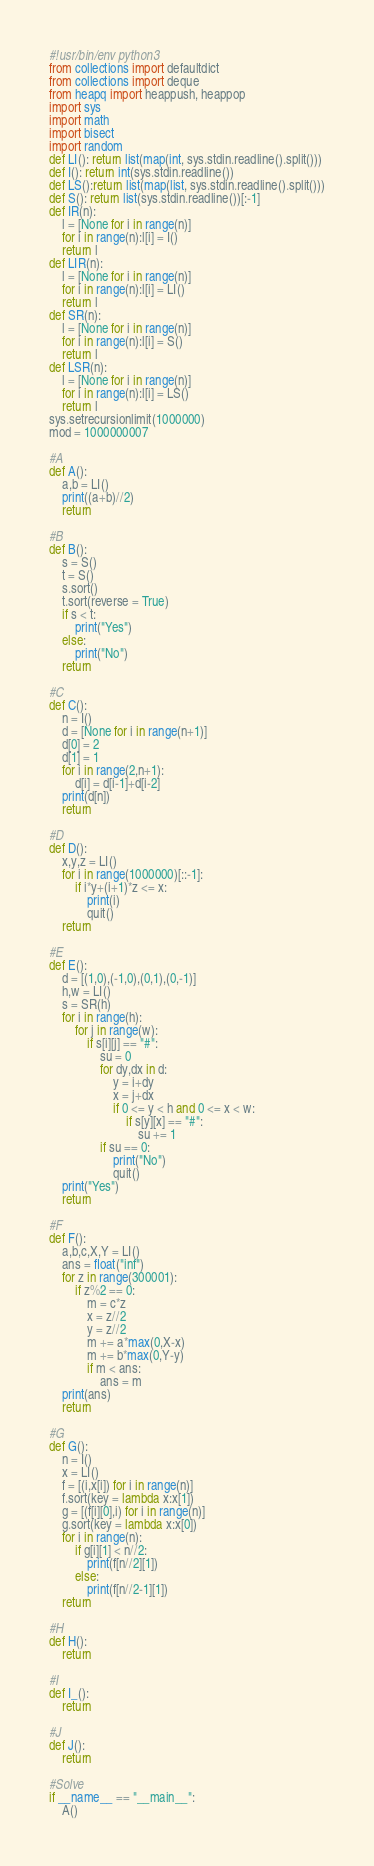<code> <loc_0><loc_0><loc_500><loc_500><_Python_>#!usr/bin/env python3
from collections import defaultdict
from collections import deque
from heapq import heappush, heappop
import sys
import math
import bisect
import random
def LI(): return list(map(int, sys.stdin.readline().split()))
def I(): return int(sys.stdin.readline())
def LS():return list(map(list, sys.stdin.readline().split()))
def S(): return list(sys.stdin.readline())[:-1]
def IR(n):
    l = [None for i in range(n)]
    for i in range(n):l[i] = I()
    return l
def LIR(n):
    l = [None for i in range(n)]
    for i in range(n):l[i] = LI()
    return l
def SR(n):
    l = [None for i in range(n)]
    for i in range(n):l[i] = S()
    return l
def LSR(n):
    l = [None for i in range(n)]
    for i in range(n):l[i] = LS()
    return l
sys.setrecursionlimit(1000000)
mod = 1000000007

#A
def A():
    a,b = LI()
    print((a+b)//2)
    return

#B
def B():
    s = S()
    t = S()
    s.sort()
    t.sort(reverse = True)
    if s < t:
        print("Yes")
    else:
        print("No")
    return

#C
def C():
    n = I()
    d = [None for i in range(n+1)]
    d[0] = 2
    d[1] = 1
    for i in range(2,n+1):
        d[i] = d[i-1]+d[i-2]
    print(d[n])
    return

#D
def D():
    x,y,z = LI()
    for i in range(1000000)[::-1]:
        if i*y+(i+1)*z <= x:
            print(i)
            quit()
    return

#E
def E():
    d = [(1,0),(-1,0),(0,1),(0,-1)]
    h,w = LI()
    s = SR(h)
    for i in range(h):
        for j in range(w):
            if s[i][j] == "#":
                su = 0
                for dy,dx in d:
                    y = i+dy
                    x = j+dx
                    if 0 <= y < h and 0 <= x < w:
                        if s[y][x] == "#":
                            su += 1
                if su == 0:
                    print("No")
                    quit()
    print("Yes")
    return

#F
def F():
    a,b,c,X,Y = LI()
    ans = float("inf")
    for z in range(300001):
        if z%2 == 0:
            m = c*z
            x = z//2
            y = z//2
            m += a*max(0,X-x)
            m += b*max(0,Y-y)
            if m < ans:
                ans = m
    print(ans)
    return

#G
def G():
    n = I()
    x = LI()
    f = [(i,x[i]) for i in range(n)]
    f.sort(key = lambda x:x[1])
    g = [(f[i][0],i) for i in range(n)]
    g.sort(key = lambda x:x[0])
    for i in range(n):
        if g[i][1] < n//2:
            print(f[n//2][1])
        else:
            print(f[n//2-1][1])
    return

#H
def H():
    return

#I
def I_():
    return

#J
def J():
    return

#Solve
if __name__ == "__main__":
    A()
</code> 